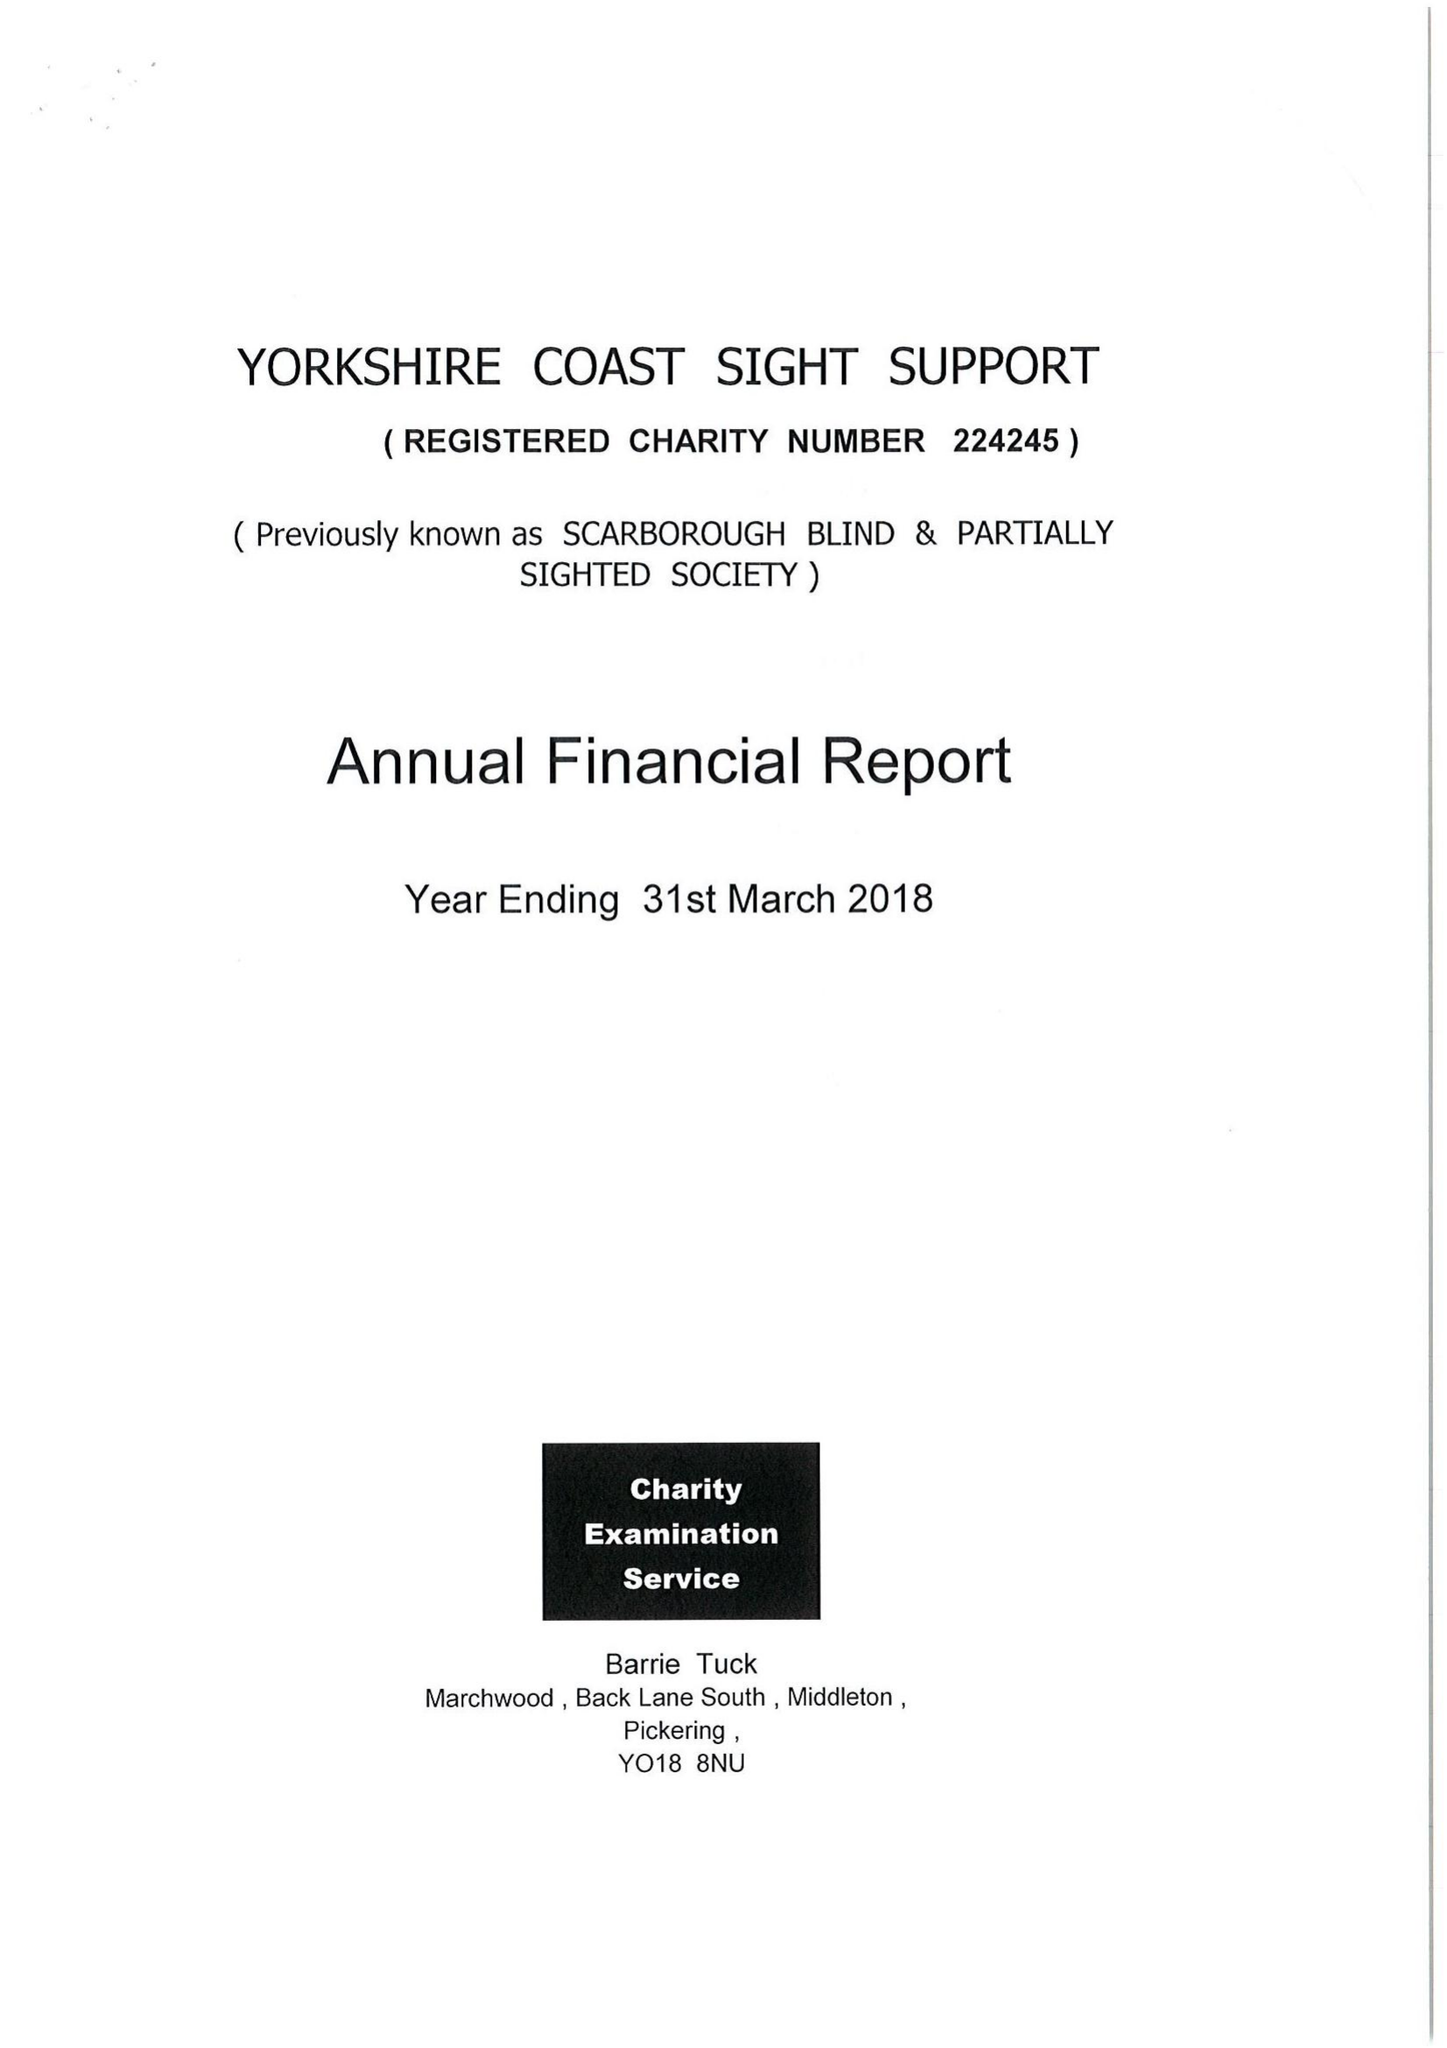What is the value for the income_annually_in_british_pounds?
Answer the question using a single word or phrase. 103987.00 